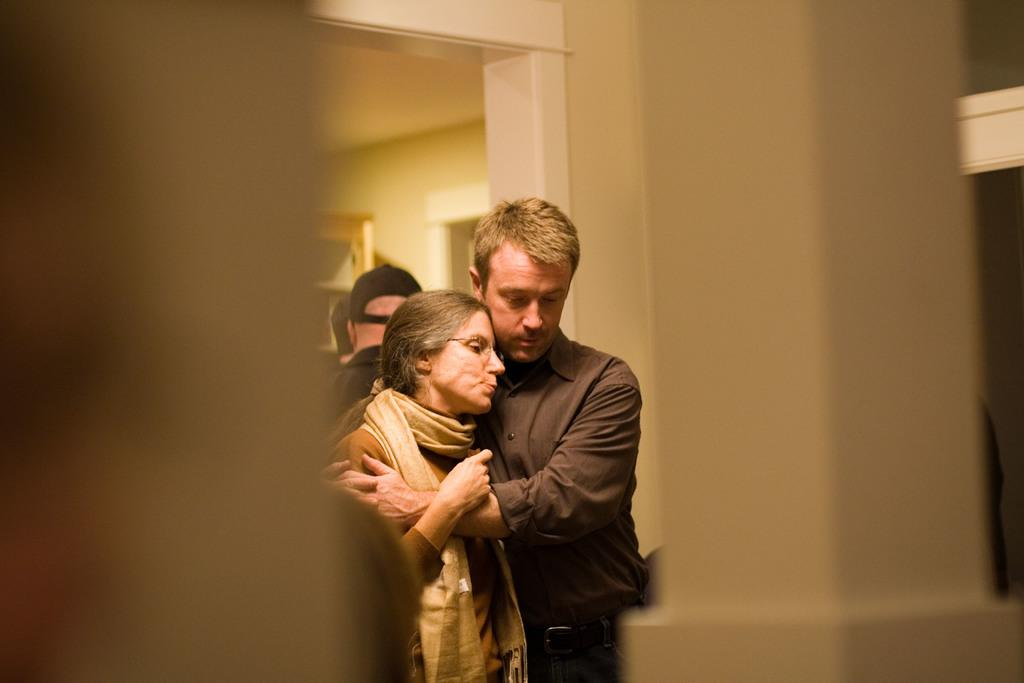Who are the two people in the image? There is a man and a woman in the image. What are the man and woman doing in the image? The man and woman are hugging. Can you describe the people in the background of the image? There are a few people in the background of the image. What type of mountain can be seen in the background of the image? There is no mountain visible in the image. What is the man thinking about while hugging the woman in the image? We cannot determine what the man is thinking about from the image alone. 